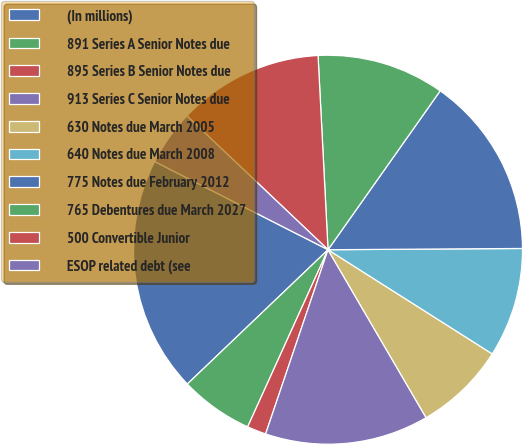<chart> <loc_0><loc_0><loc_500><loc_500><pie_chart><fcel>(In millions)<fcel>891 Series A Senior Notes due<fcel>895 Series B Senior Notes due<fcel>913 Series C Senior Notes due<fcel>630 Notes due March 2005<fcel>640 Notes due March 2008<fcel>775 Notes due February 2012<fcel>765 Debentures due March 2027<fcel>500 Convertible Junior<fcel>ESOP related debt (see<nl><fcel>19.62%<fcel>6.09%<fcel>1.58%<fcel>13.61%<fcel>7.59%<fcel>9.1%<fcel>15.11%<fcel>10.6%<fcel>12.1%<fcel>4.59%<nl></chart> 